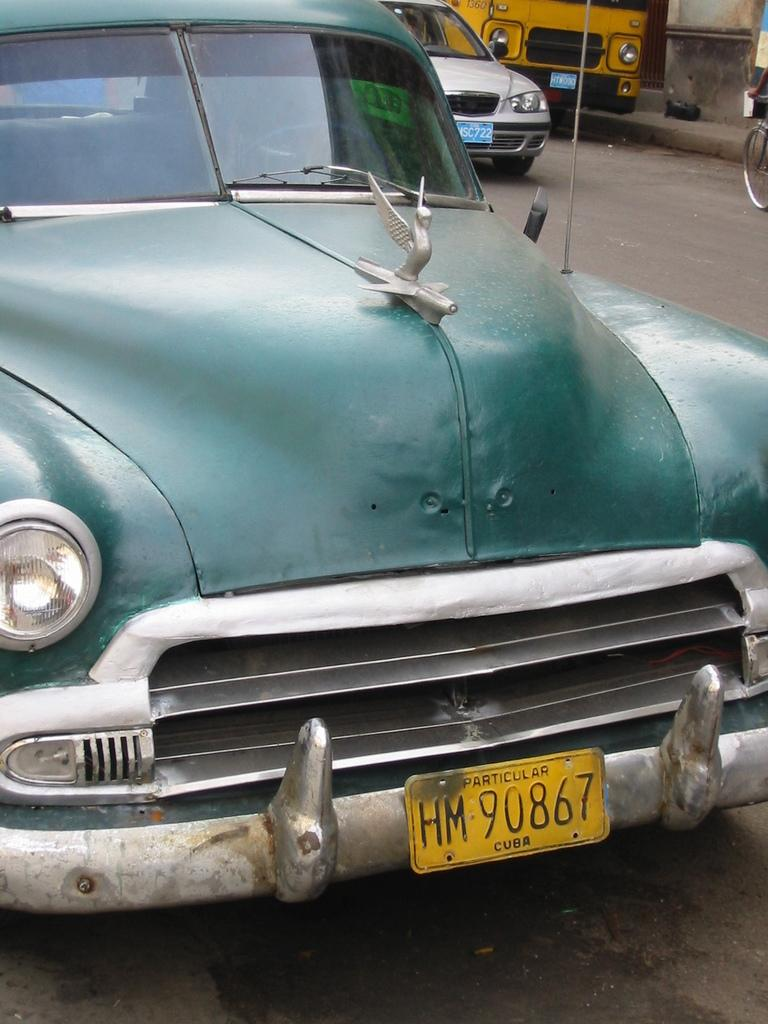<image>
Present a compact description of the photo's key features. Street in Cuba with a green car in focus. 